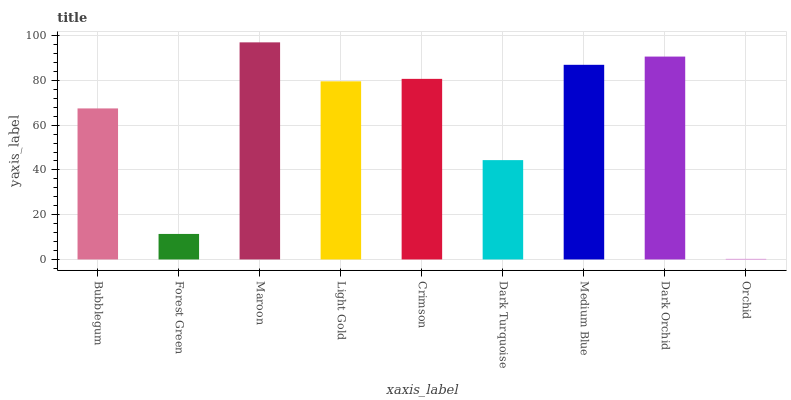Is Orchid the minimum?
Answer yes or no. Yes. Is Maroon the maximum?
Answer yes or no. Yes. Is Forest Green the minimum?
Answer yes or no. No. Is Forest Green the maximum?
Answer yes or no. No. Is Bubblegum greater than Forest Green?
Answer yes or no. Yes. Is Forest Green less than Bubblegum?
Answer yes or no. Yes. Is Forest Green greater than Bubblegum?
Answer yes or no. No. Is Bubblegum less than Forest Green?
Answer yes or no. No. Is Light Gold the high median?
Answer yes or no. Yes. Is Light Gold the low median?
Answer yes or no. Yes. Is Crimson the high median?
Answer yes or no. No. Is Forest Green the low median?
Answer yes or no. No. 